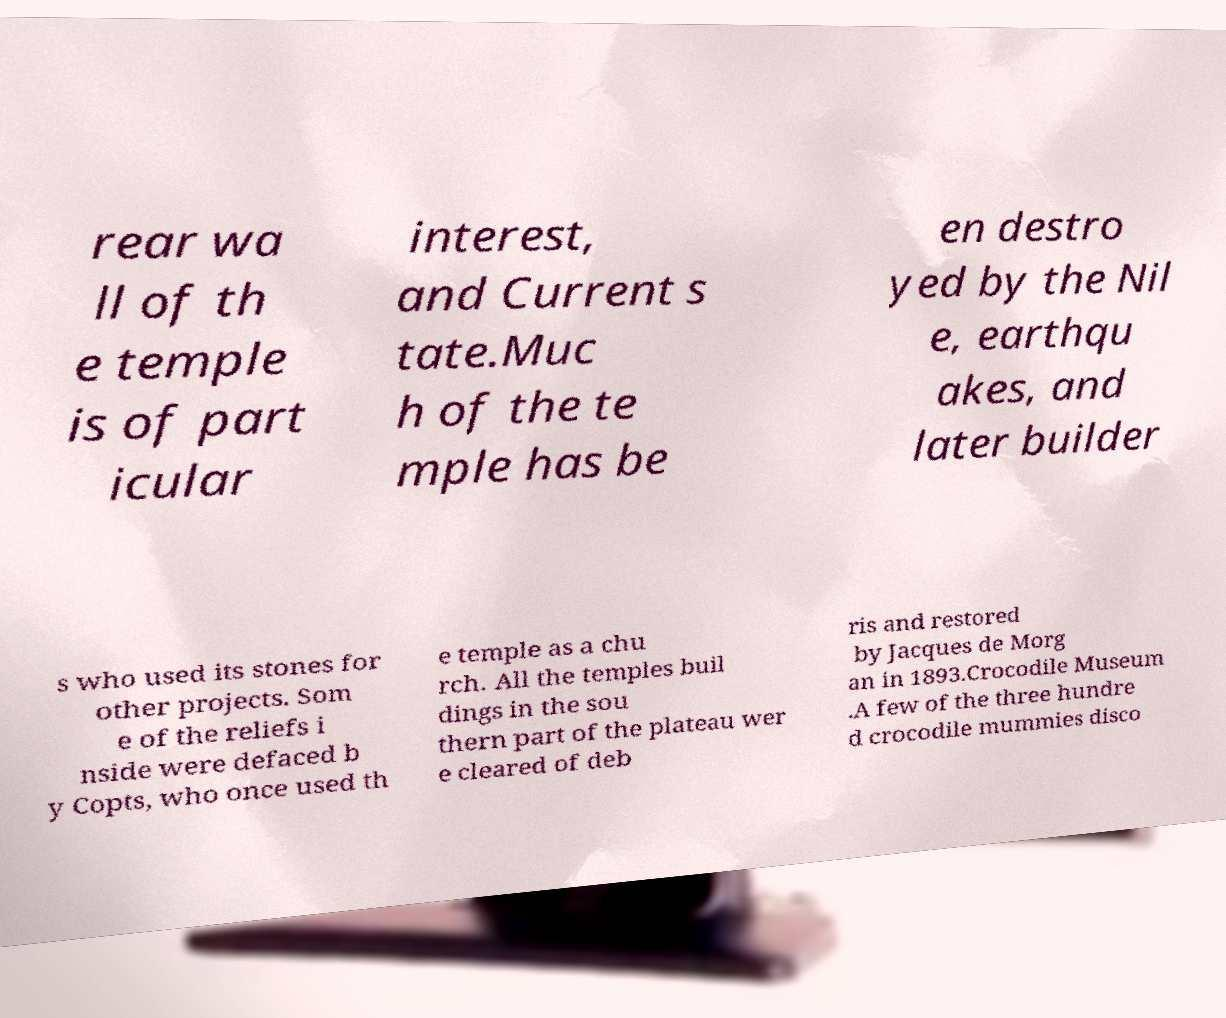Please read and relay the text visible in this image. What does it say? rear wa ll of th e temple is of part icular interest, and Current s tate.Muc h of the te mple has be en destro yed by the Nil e, earthqu akes, and later builder s who used its stones for other projects. Som e of the reliefs i nside were defaced b y Copts, who once used th e temple as a chu rch. All the temples buil dings in the sou thern part of the plateau wer e cleared of deb ris and restored by Jacques de Morg an in 1893.Crocodile Museum .A few of the three hundre d crocodile mummies disco 